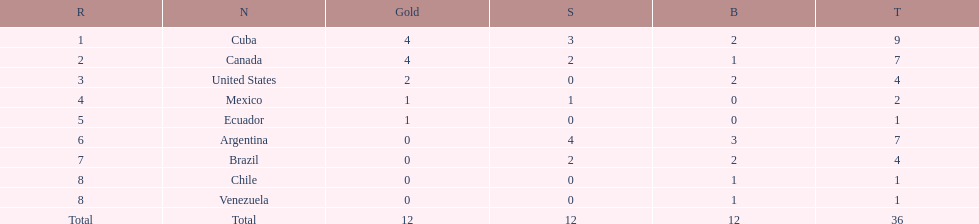Who had more silver medals, cuba or brazil? Cuba. 